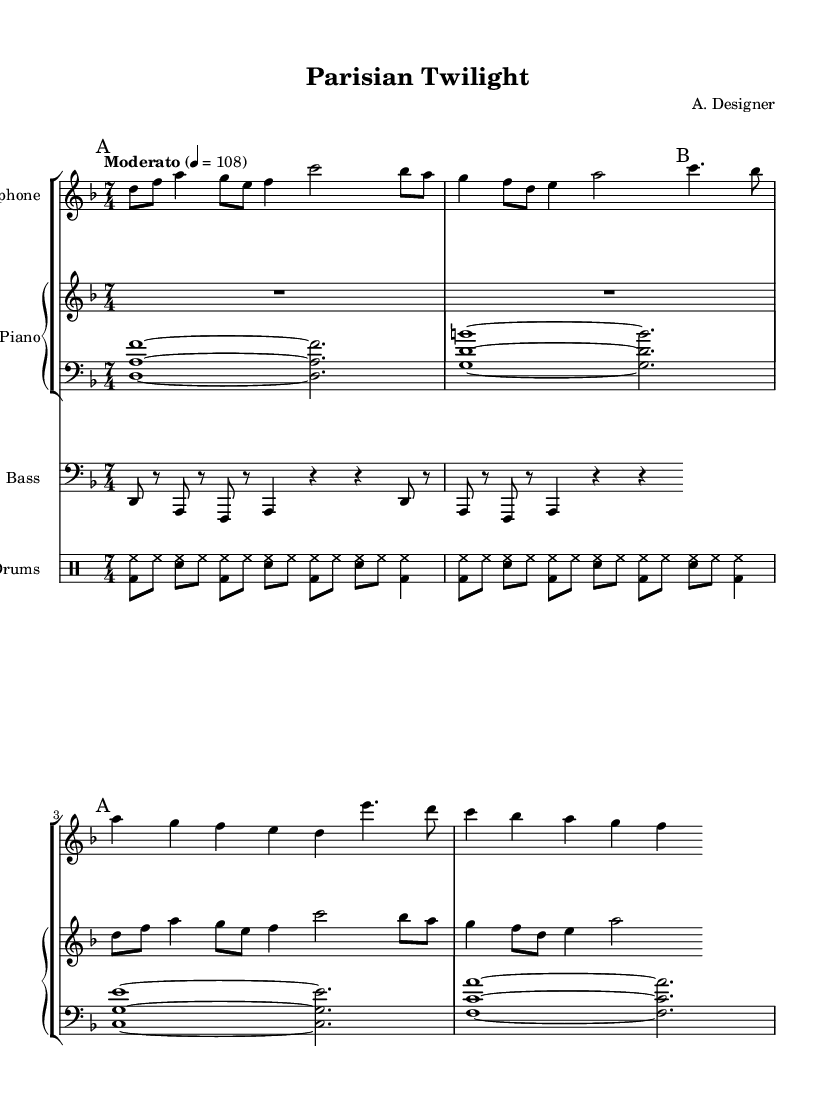What is the key signature of this music? The key signature is indicated at the beginning of the score; here it shows no sharps or flats, which means it is D minor.
Answer: D minor What is the time signature of this piece? The time signature is shown at the beginning as a fraction that indicates how many beats are in each measure; it shows 7 over 4, meaning each measure has 7 beats, and the quarter note gets one beat.
Answer: 7/4 What is the tempo marking for this composition? The tempo marking is located at the beginning of the score and describes the speed of the music; it indicates "Moderato" at a metronome marking of 108, suggesting a moderate tempo.
Answer: Moderato, 108 How many measures are in the saxophone part? By counting the separate segments marked in the saxophone music section, there are a total of four measures in the part, with some measures indicating different melodic phrases.
Answer: 4 In which section do we find the first melody of the piece? The first melody occurs at the start of the saxophone music, which is marked "A"; this is the opening section and introduces the main melodic theme.
Answer: Section A What rhythmic value does the piano's right hand primarily use? Observing the right hand piano part, it starts with some rests followed by eighth notes and quarter notes; overall, it emphasizes a mixture of eighth and quarter note values throughout the section.
Answer: Eighth and quarter notes How does the bass line relate rhythmically to the drum pattern? The bass line predominantly uses a repeated rhythmic pattern of eighth notes and rests, while the drum pattern uses a consistent combination of bass drum and snare hits, creating a foundational groove that supports the bass line.
Answer: Repeated rhythmic pattern 